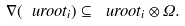Convert formula to latex. <formula><loc_0><loc_0><loc_500><loc_500>\nabla ( \ u r o o t _ { i } ) \subseteq \ u r o o t _ { i } \otimes \Omega .</formula> 